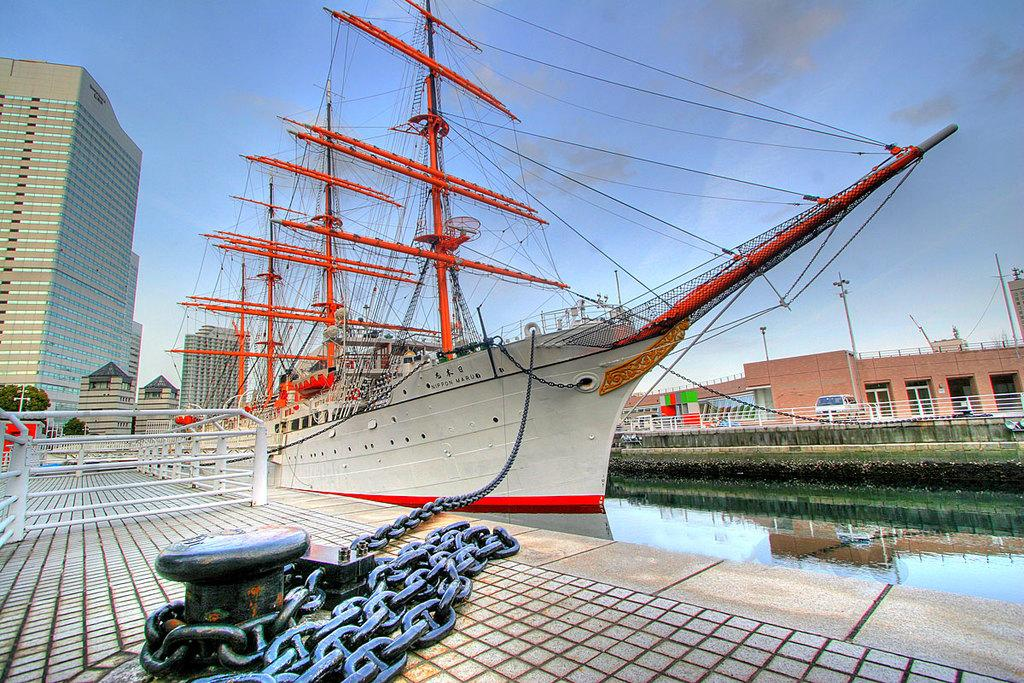What is the main element present in the image? There is water in the image. What can be seen on the left side of the image? There is a chain and rail on the left side of the image. What type of vehicle is in the image? There is a ship in the image. What can be seen in the background of the image? There are buildings and clouds in the sky in the background of the image. What type of growth can be seen on the roof of the ship in the image? There is no roof on the ship in the image, and therefore no growth can be observed. 